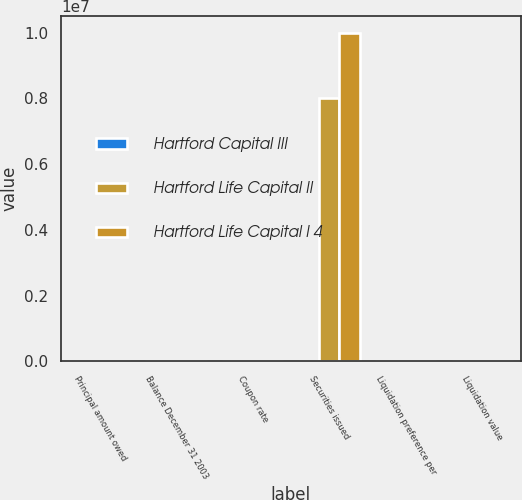Convert chart to OTSL. <chart><loc_0><loc_0><loc_500><loc_500><stacked_bar_chart><ecel><fcel>Principal amount owed<fcel>Balance December 31 2003<fcel>Coupon rate<fcel>Securities issued<fcel>Liquidation preference per<fcel>Liquidation value<nl><fcel>Hartford Capital III<fcel>500<fcel>507<fcel>7.45<fcel>200<fcel>25<fcel>500<nl><fcel>Hartford Life Capital II<fcel>200<fcel>200<fcel>7.62<fcel>8e+06<fcel>25<fcel>200<nl><fcel>Hartford Life Capital I 4<fcel>250<fcel>245<fcel>7.2<fcel>1e+07<fcel>25<fcel>250<nl></chart> 